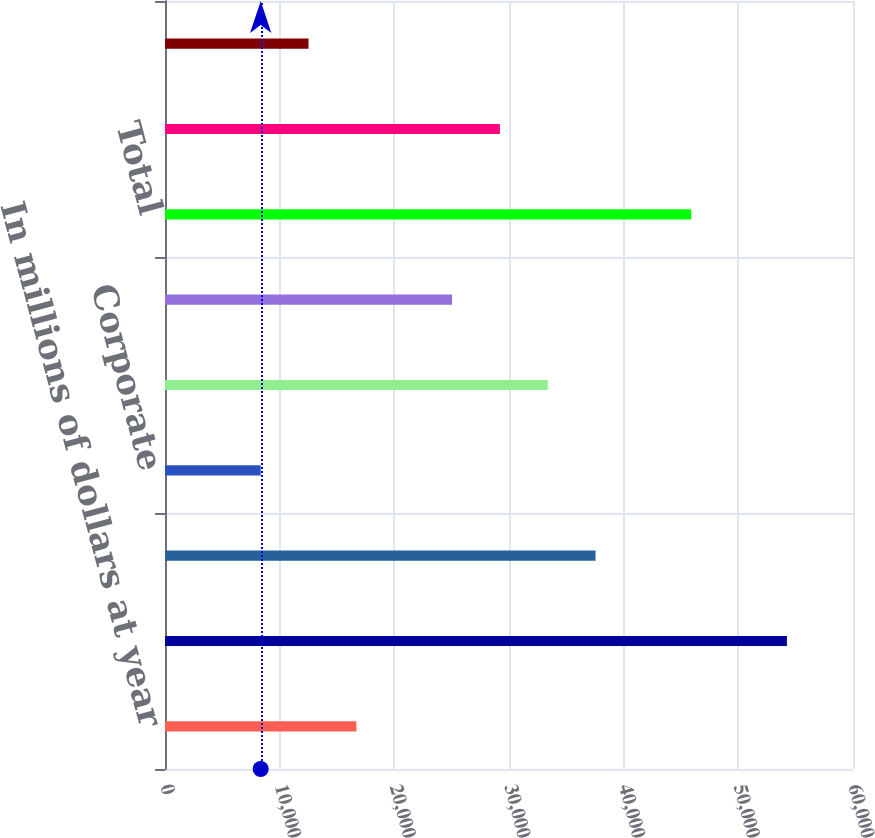Convert chart to OTSL. <chart><loc_0><loc_0><loc_500><loc_500><bar_chart><fcel>In millions of dollars at year<fcel>Allowance for loan losses at<fcel>Consumer<fcel>Corporate<fcel>In US offices<fcel>In offices outside the US<fcel>Total<fcel>Other-net (1)<fcel>Allowance for unfunded lending<nl><fcel>16689.2<fcel>54236.9<fcel>37549<fcel>8345.22<fcel>33377<fcel>25033.1<fcel>45892.9<fcel>29205.1<fcel>12517.2<nl></chart> 